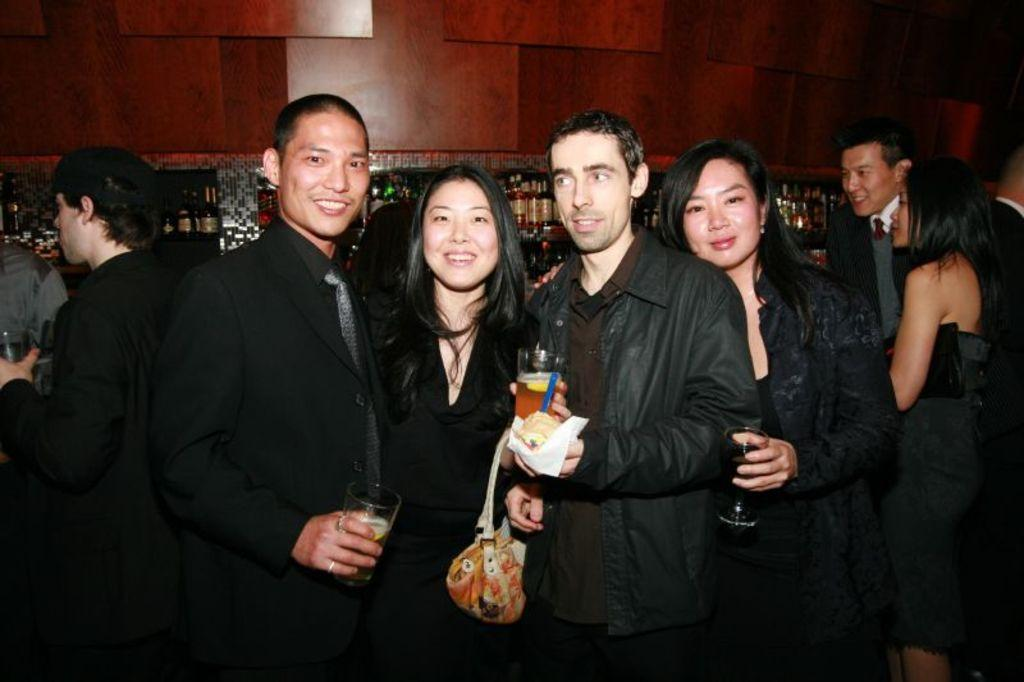What are the people in the image doing? The people in the image are standing. What objects are some of the people holding in their hands? Some of the people are holding glasses in their hands. What accessory is the woman wearing? The woman is wearing a handbag. What can be seen in the background of the image? There are bottles visible in the background of the image. What type of fish can be seen swimming in the handbag of the woman in the image? There is no fish present in the image, and the woman's handbag does not contain any water or aquatic environment for a fish to swim in. 